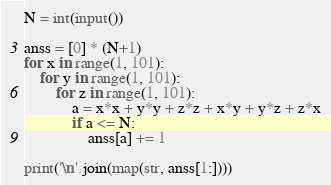<code> <loc_0><loc_0><loc_500><loc_500><_Python_>N = int(input())

anss = [0] * (N+1)
for x in range(1, 101):
    for y in range(1, 101):
        for z in range(1, 101):
            a = x*x + y*y + z*z + x*y + y*z + z*x
            if a <= N:
                anss[a] += 1

print('\n'.join(map(str, anss[1:])))
</code> 